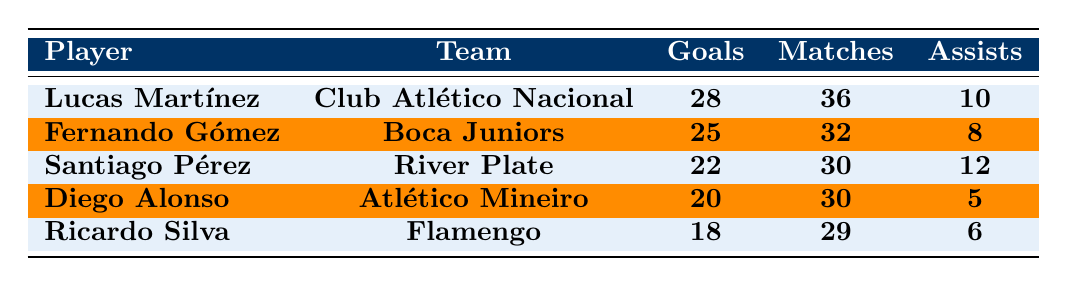What is the total number of goals scored by the top scorer? The top scorer is Lucas Martínez, who scored 28 goals.
Answer: 28 Which player has the highest number of assists? Santiago Pérez has the most assists with a total of 12.
Answer: Santiago Pérez How many goals did Fernando Gómez score? Fernando Gómez scored 25 goals in the tournament.
Answer: 25 What is the average number of goals scored by players listed in the table? The total goals scored are 28 + 25 + 22 + 20 + 18 = 113. There are 5 players, so the average is 113/5 = 22.6.
Answer: 22.6 Did Diego Alonso score more goals than Ricardo Silva? Diego Alonso scored 20 goals, while Ricardo Silva scored 18 goals, so the answer is yes.
Answer: Yes Which team did Santiago Pérez represent? Santiago Pérez played for River Plate.
Answer: River Plate How many players scored at least 20 goals? Lucas Martínez (28), Fernando Gómez (25), Santiago Pérez (22), and Diego Alonso (20) all scored 20 or more goals, which makes 4 players.
Answer: 4 Is it true that all players listed participated in at least 30 matches? No, Lucas Martínez played 36 matches, Fernando Gómez 32 matches, but both Santiago Pérez and Diego Alonso played 30 matches, which is not "at least 30" considering the prompt only refers to players playing more than 30 matches.
Answer: No What is the difference in goals between the top scorer and the player with the least goals? The top scorer Lucas Martínez scored 28 goals, while the player with the least goals, Ricardo Silva, scored 18 goals. The difference is 28 - 18 = 10 goals.
Answer: 10 Which player's contribution in terms of assists is higher than their goals? Diego Alonso scored 20 goals and made 5 assists, while Ricardo Silva scored 18 goals and made 6 assists; hence no player has more assists than goals.
Answer: No 